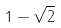Convert formula to latex. <formula><loc_0><loc_0><loc_500><loc_500>1 - \sqrt { 2 }</formula> 